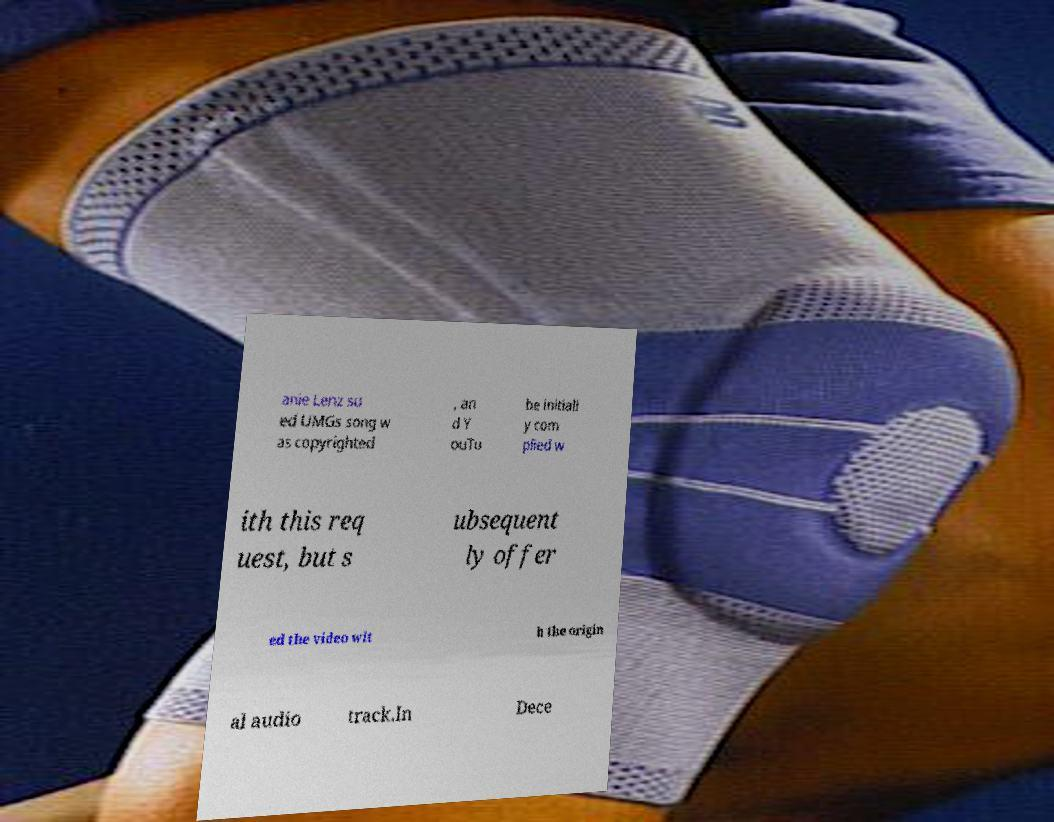Can you accurately transcribe the text from the provided image for me? anie Lenz su ed UMGs song w as copyrighted , an d Y ouTu be initiall y com plied w ith this req uest, but s ubsequent ly offer ed the video wit h the origin al audio track.In Dece 